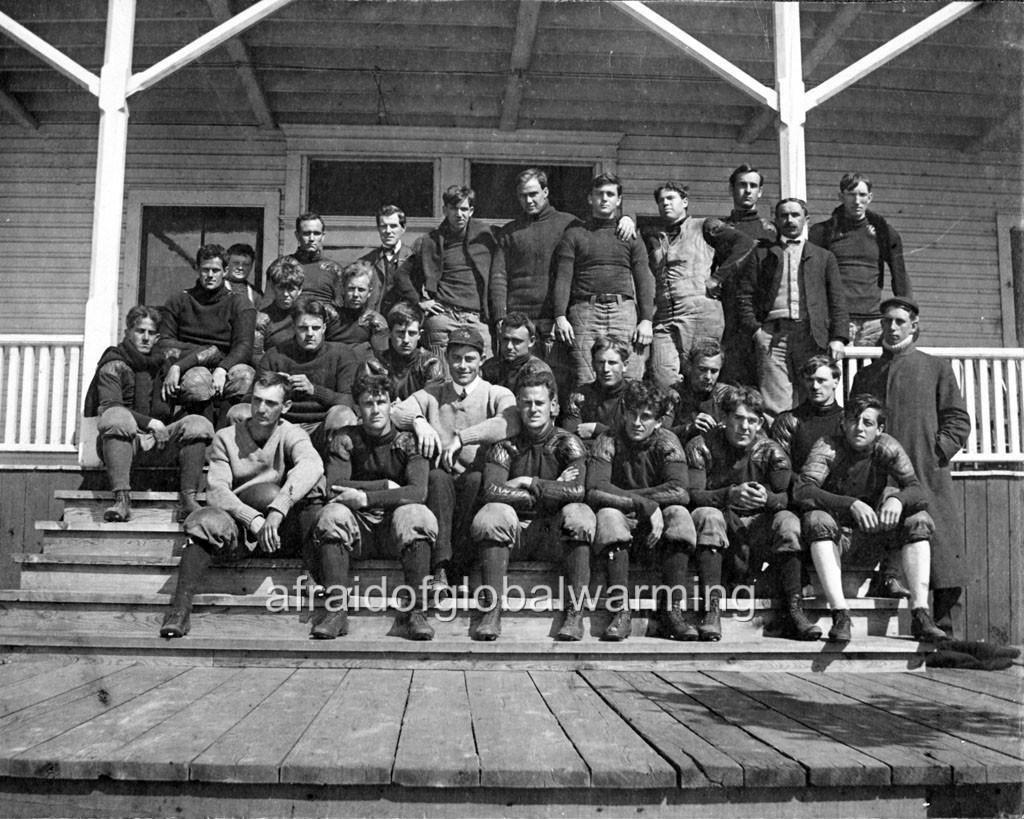Please provide a concise description of this image. In this black and white picture few persons are sitting on the stairs. Few persons are standing on the floor. Behind them there is a house having fence. 